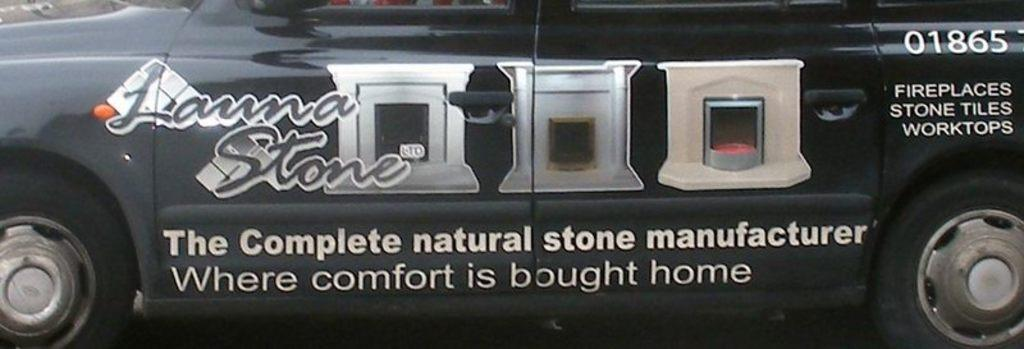What is the main subject of the image? There is a car in the image. What is the color of the car? The car is black in color. What can be seen on the car besides its color? There are images and words on the car. What type of fiction is the car reading in the image? There is no indication in the image that the car is reading any fiction, as cars do not have the ability to read. 